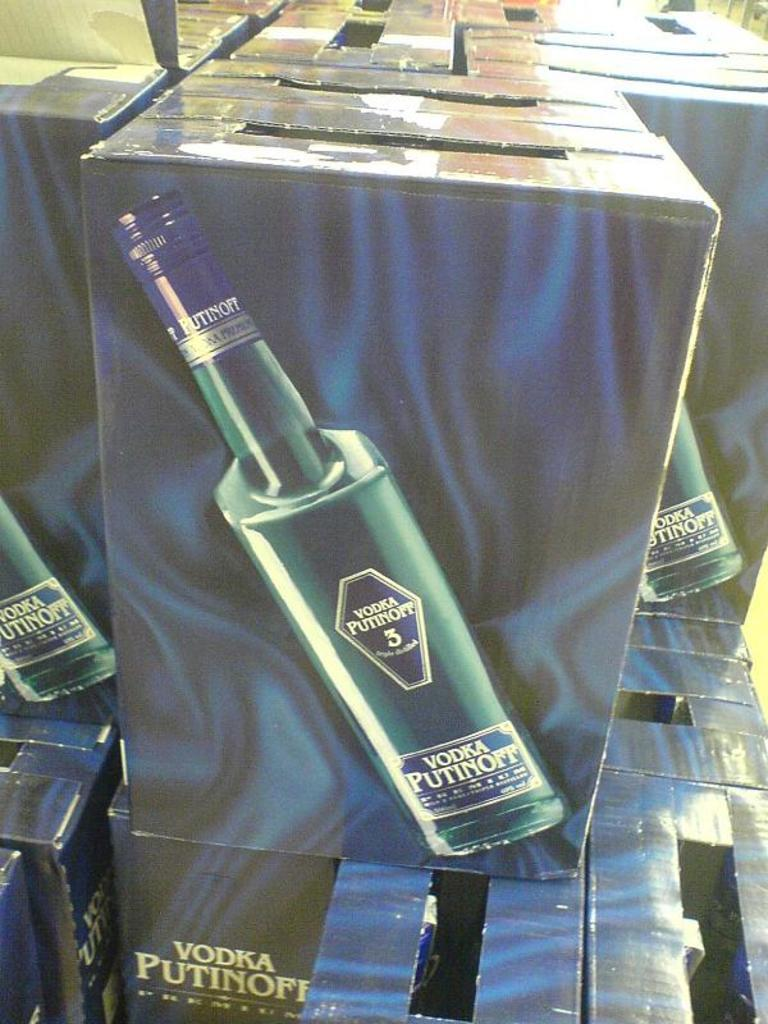<image>
Write a terse but informative summary of the picture. A bottle of Vodka Putinoff is shows on the side of a cardboard box. 